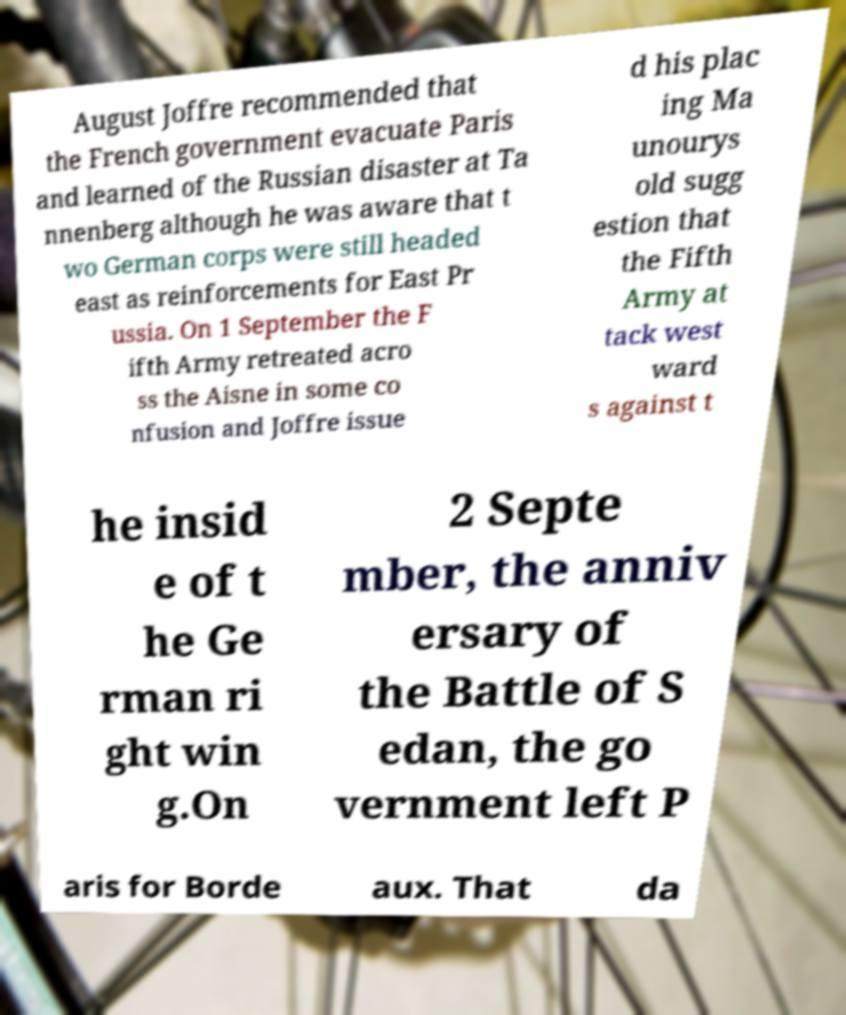Please read and relay the text visible in this image. What does it say? August Joffre recommended that the French government evacuate Paris and learned of the Russian disaster at Ta nnenberg although he was aware that t wo German corps were still headed east as reinforcements for East Pr ussia. On 1 September the F ifth Army retreated acro ss the Aisne in some co nfusion and Joffre issue d his plac ing Ma unourys old sugg estion that the Fifth Army at tack west ward s against t he insid e of t he Ge rman ri ght win g.On 2 Septe mber, the anniv ersary of the Battle of S edan, the go vernment left P aris for Borde aux. That da 